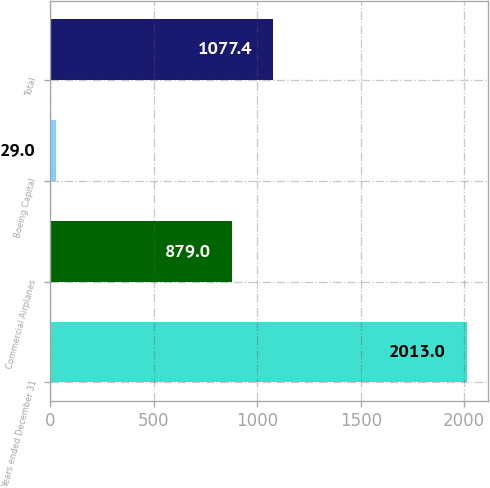Convert chart to OTSL. <chart><loc_0><loc_0><loc_500><loc_500><bar_chart><fcel>Years ended December 31<fcel>Commercial Airplanes<fcel>Boeing Capital<fcel>Total<nl><fcel>2013<fcel>879<fcel>29<fcel>1077.4<nl></chart> 